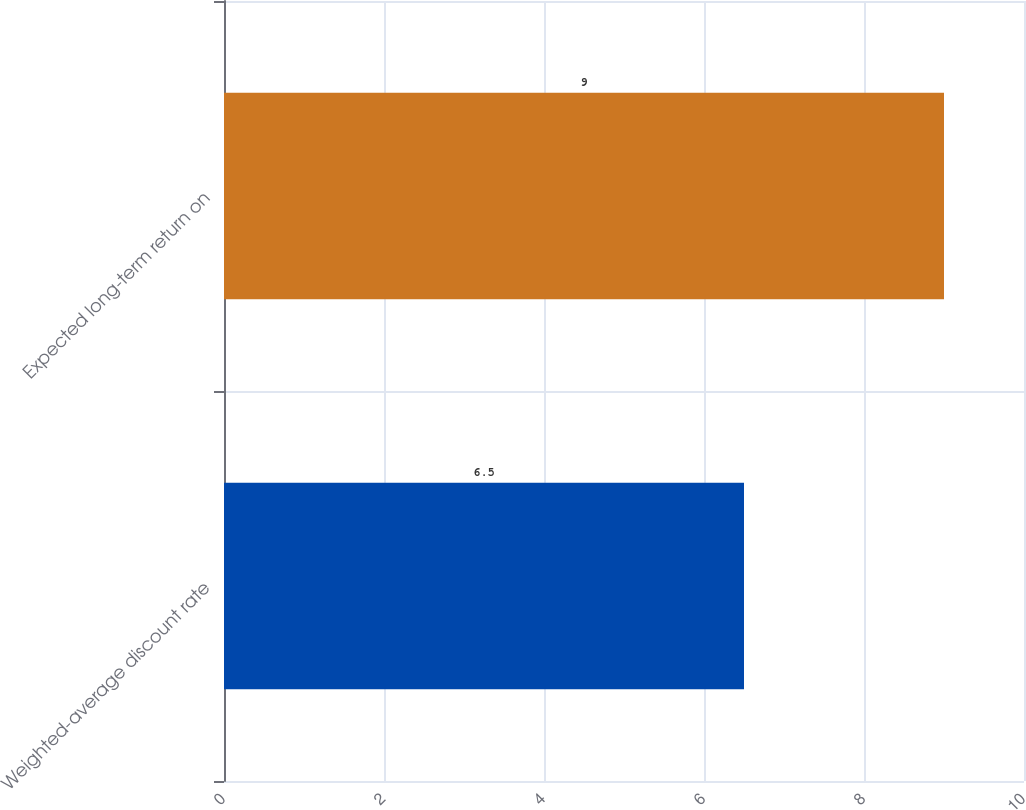Convert chart to OTSL. <chart><loc_0><loc_0><loc_500><loc_500><bar_chart><fcel>Weighted-average discount rate<fcel>Expected long-term return on<nl><fcel>6.5<fcel>9<nl></chart> 